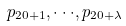Convert formula to latex. <formula><loc_0><loc_0><loc_500><loc_500>p _ { 2 0 + 1 } , \cdot \cdot \cdot , p _ { 2 0 + \lambda }</formula> 